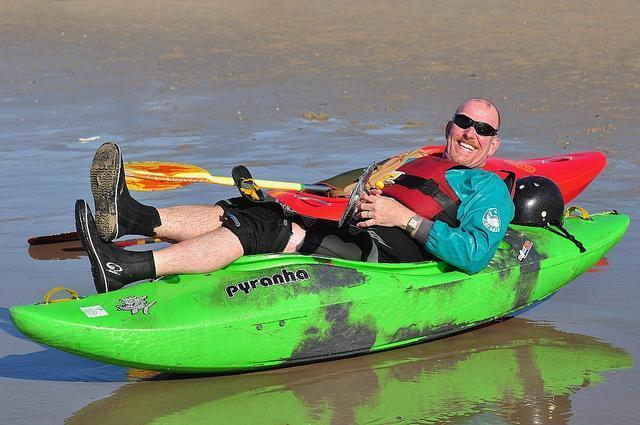Is the given caption "The person is on top of the boat." fitting for the image?
Answer yes or no. Yes. 